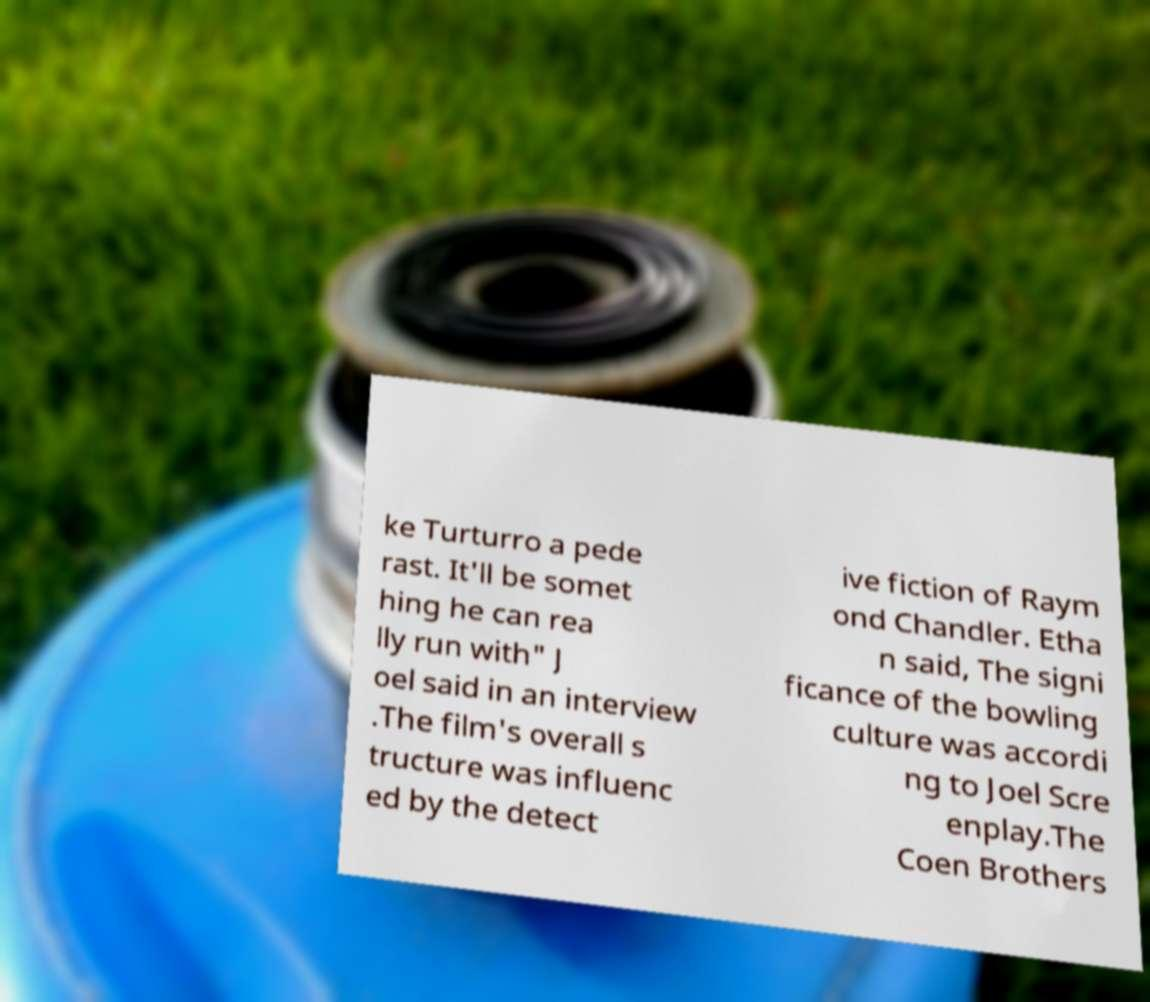Please identify and transcribe the text found in this image. ke Turturro a pede rast. It'll be somet hing he can rea lly run with" J oel said in an interview .The film's overall s tructure was influenc ed by the detect ive fiction of Raym ond Chandler. Etha n said, The signi ficance of the bowling culture was accordi ng to Joel Scre enplay.The Coen Brothers 